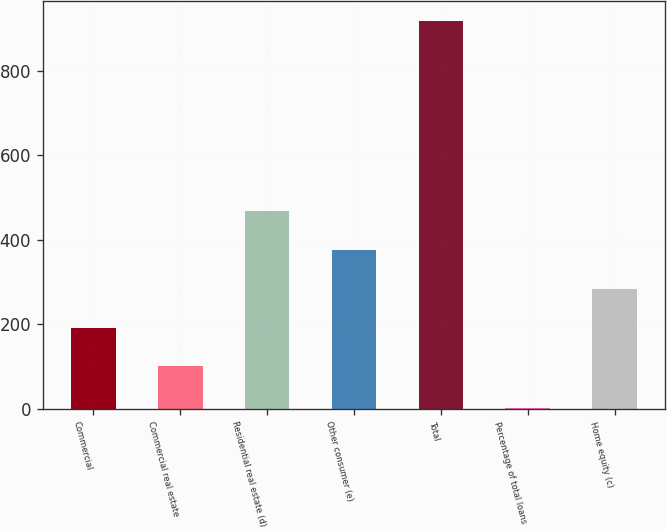Convert chart. <chart><loc_0><loc_0><loc_500><loc_500><bar_chart><fcel>Commercial<fcel>Commercial real estate<fcel>Residential real estate (d)<fcel>Other consumer (e)<fcel>Total<fcel>Percentage of total loans<fcel>Home equity (c)<nl><fcel>191.85<fcel>100<fcel>467.4<fcel>375.55<fcel>919<fcel>0.49<fcel>283.7<nl></chart> 